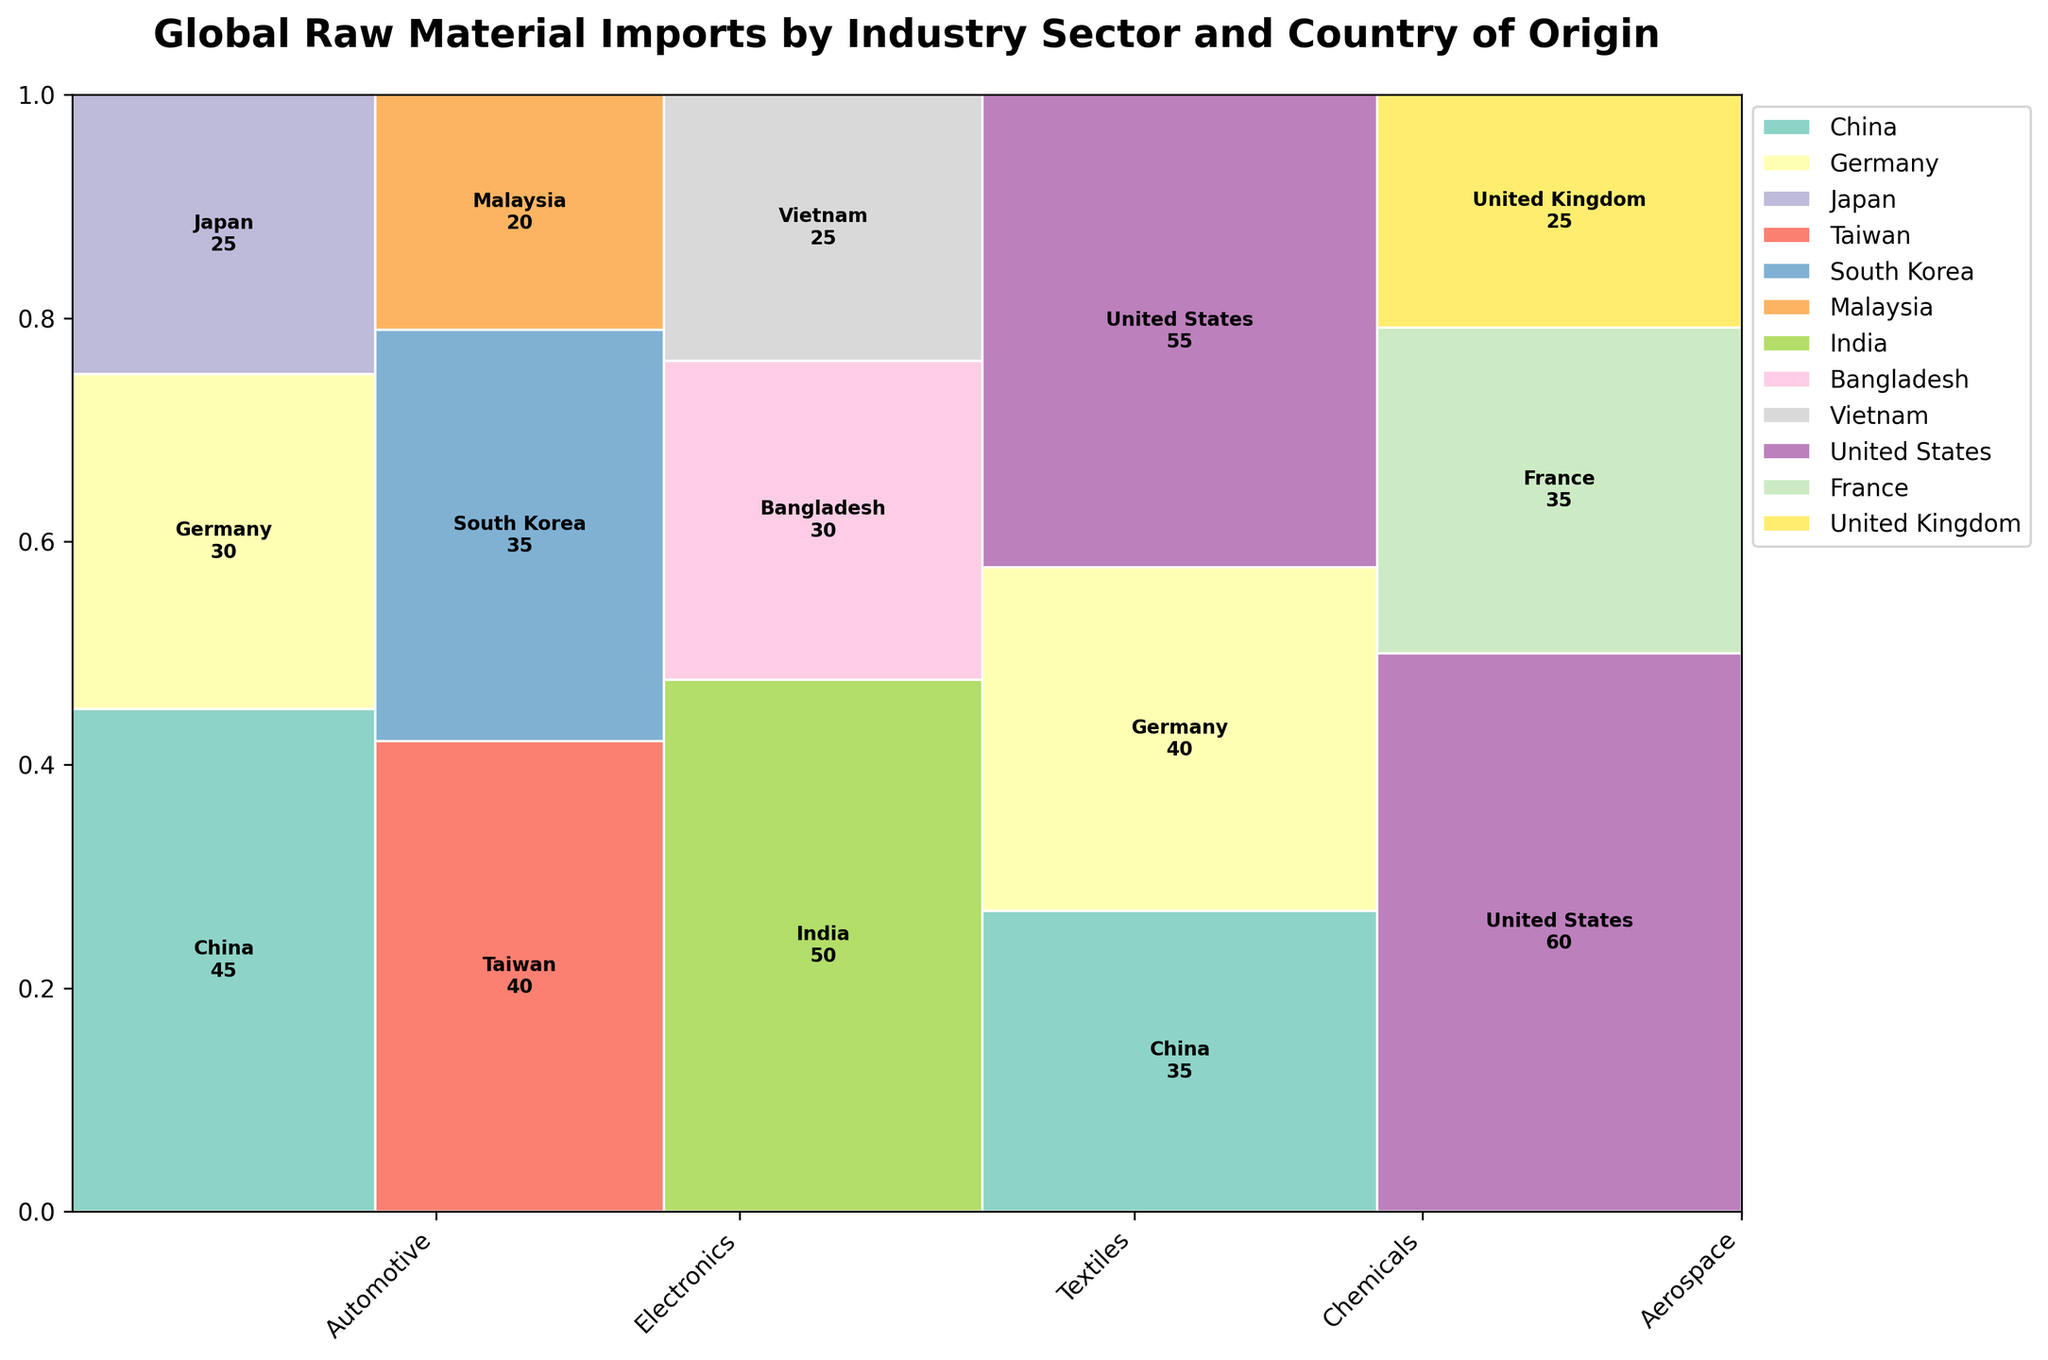What is the title of the figure? The title of the figure is displayed at the top. It helps to understand the context of the visualization.
Answer: Global Raw Material Imports by Industry Sector and Country of Origin How many industry sectors are represented in the plot? By looking at the x-axis labels, we can count the distinct industry sectors represented.
Answer: 5 Which country contributes the most to the Chemicals industry? By comparing the heights of the rectangles within the Chemicals section, the tallest rectangle indicates the highest contribution.
Answer: United States What is the total value of raw material imports for the Aerospace industry? Sum the values from the rectangles representing the Aerospace sector. The values are 60 (United States), 35 (France), and 25 (United Kingdom).
Answer: 120 Which industry sector has the smallest width in the plot? The width of each industry sector is proportional to the total value imported. By comparing the widths, the narrowest sector is the smallest.
Answer: Textiles How does the contribution of China compare between the Chemicals and Automotive industries? By observing the heights of the rectangles representing China in both industries, we can compare their contributions. The taller rectangle indicates a greater value.
Answer: Chemical > Automotive Which country contributes equally to the Textiles and Automotive industries? By observing the height of the rectangles representing the Textiles and Automotive industries, look for two rectangles with the same height indicating equal contributions.
Answer: Vietnam Which industry has the highest number of contributing countries? By counting the number of distinct rectangles within each industry, the industry with the most rectangles has the highest number of contributing countries.
Answer: Electronics What is the total contribution of Germany across all industries? Identify and sum the heights of all rectangles representing Germany. The values are 40 (Chemicals), 30 (Automotive), and 35 (Aerospace).
Answer: 105 What proportion of total imports does the Automotive sector represent compared to Electronics? Sum the total values of imports for the Automotive sector (45+30+25) and Electronics sector (40+35+20), then calculate the proportion.
Answer: 100/95 